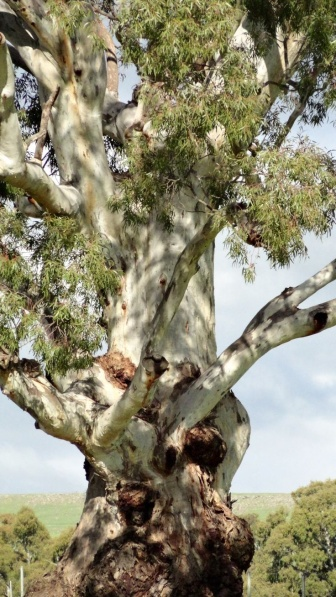Could you tell me about the habitat this type of tree typically thrives in? This eucalyptus tree is indicative of a species well adapted to a variety of habitats, yet they are most commonly associated with regions that experience a Mediterranean climate - dry summers and wet winters. They are also prevalent in temperate zones and are known for their ability to withstand poor soil quality, drought, and fire. As such, eucalyptus trees are a fundamental component of their ecosystems, providing essential shelter and food for wildlife, particularly in Australian landscapes where they are predominant. 